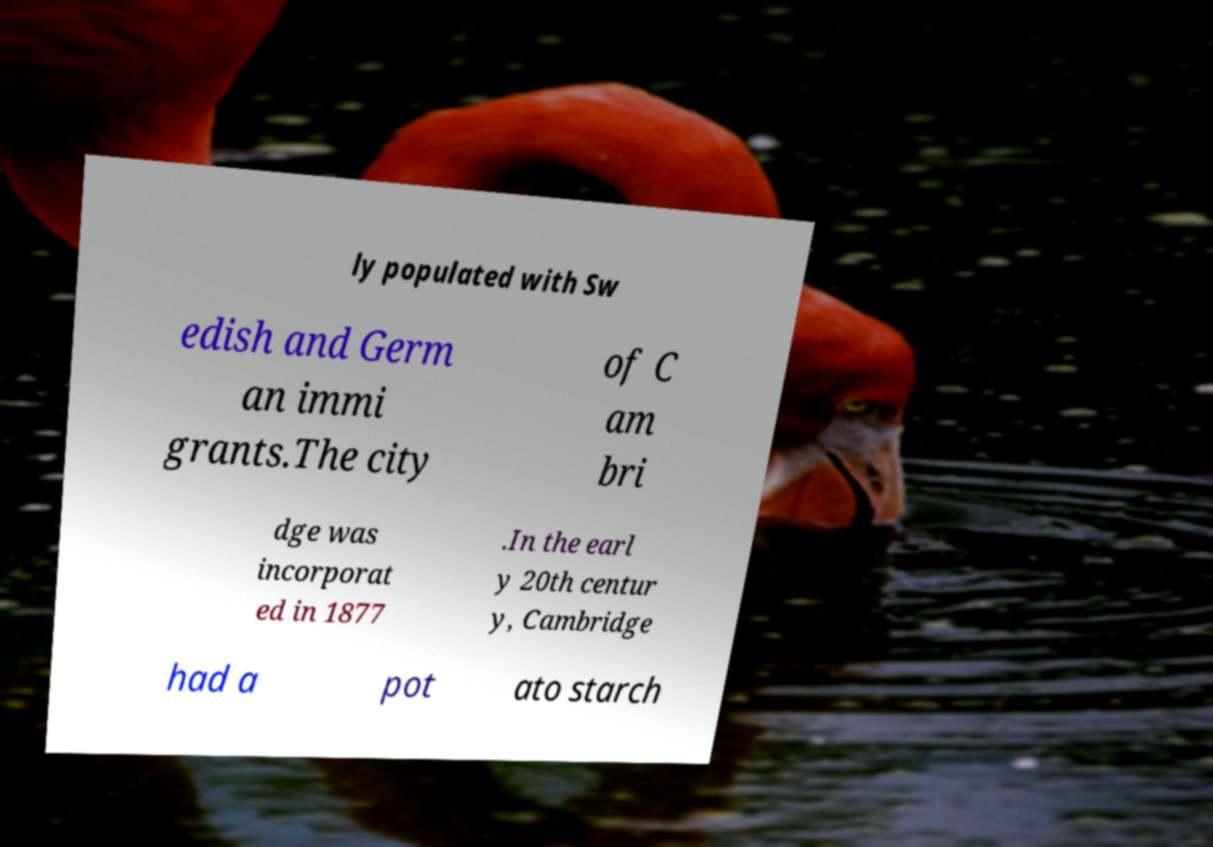I need the written content from this picture converted into text. Can you do that? ly populated with Sw edish and Germ an immi grants.The city of C am bri dge was incorporat ed in 1877 .In the earl y 20th centur y, Cambridge had a pot ato starch 